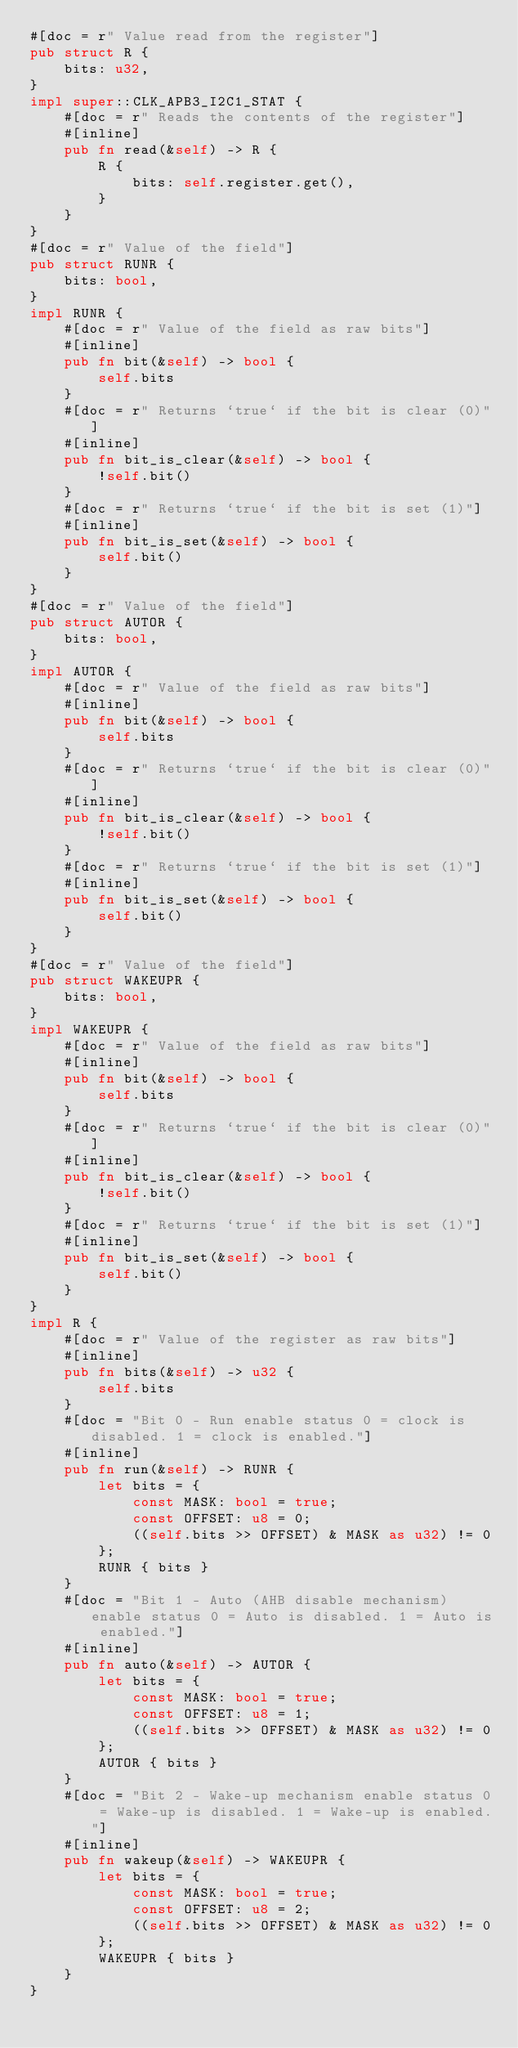Convert code to text. <code><loc_0><loc_0><loc_500><loc_500><_Rust_>#[doc = r" Value read from the register"]
pub struct R {
    bits: u32,
}
impl super::CLK_APB3_I2C1_STAT {
    #[doc = r" Reads the contents of the register"]
    #[inline]
    pub fn read(&self) -> R {
        R {
            bits: self.register.get(),
        }
    }
}
#[doc = r" Value of the field"]
pub struct RUNR {
    bits: bool,
}
impl RUNR {
    #[doc = r" Value of the field as raw bits"]
    #[inline]
    pub fn bit(&self) -> bool {
        self.bits
    }
    #[doc = r" Returns `true` if the bit is clear (0)"]
    #[inline]
    pub fn bit_is_clear(&self) -> bool {
        !self.bit()
    }
    #[doc = r" Returns `true` if the bit is set (1)"]
    #[inline]
    pub fn bit_is_set(&self) -> bool {
        self.bit()
    }
}
#[doc = r" Value of the field"]
pub struct AUTOR {
    bits: bool,
}
impl AUTOR {
    #[doc = r" Value of the field as raw bits"]
    #[inline]
    pub fn bit(&self) -> bool {
        self.bits
    }
    #[doc = r" Returns `true` if the bit is clear (0)"]
    #[inline]
    pub fn bit_is_clear(&self) -> bool {
        !self.bit()
    }
    #[doc = r" Returns `true` if the bit is set (1)"]
    #[inline]
    pub fn bit_is_set(&self) -> bool {
        self.bit()
    }
}
#[doc = r" Value of the field"]
pub struct WAKEUPR {
    bits: bool,
}
impl WAKEUPR {
    #[doc = r" Value of the field as raw bits"]
    #[inline]
    pub fn bit(&self) -> bool {
        self.bits
    }
    #[doc = r" Returns `true` if the bit is clear (0)"]
    #[inline]
    pub fn bit_is_clear(&self) -> bool {
        !self.bit()
    }
    #[doc = r" Returns `true` if the bit is set (1)"]
    #[inline]
    pub fn bit_is_set(&self) -> bool {
        self.bit()
    }
}
impl R {
    #[doc = r" Value of the register as raw bits"]
    #[inline]
    pub fn bits(&self) -> u32 {
        self.bits
    }
    #[doc = "Bit 0 - Run enable status 0 = clock is disabled. 1 = clock is enabled."]
    #[inline]
    pub fn run(&self) -> RUNR {
        let bits = {
            const MASK: bool = true;
            const OFFSET: u8 = 0;
            ((self.bits >> OFFSET) & MASK as u32) != 0
        };
        RUNR { bits }
    }
    #[doc = "Bit 1 - Auto (AHB disable mechanism) enable status 0 = Auto is disabled. 1 = Auto is enabled."]
    #[inline]
    pub fn auto(&self) -> AUTOR {
        let bits = {
            const MASK: bool = true;
            const OFFSET: u8 = 1;
            ((self.bits >> OFFSET) & MASK as u32) != 0
        };
        AUTOR { bits }
    }
    #[doc = "Bit 2 - Wake-up mechanism enable status 0 = Wake-up is disabled. 1 = Wake-up is enabled."]
    #[inline]
    pub fn wakeup(&self) -> WAKEUPR {
        let bits = {
            const MASK: bool = true;
            const OFFSET: u8 = 2;
            ((self.bits >> OFFSET) & MASK as u32) != 0
        };
        WAKEUPR { bits }
    }
}
</code> 